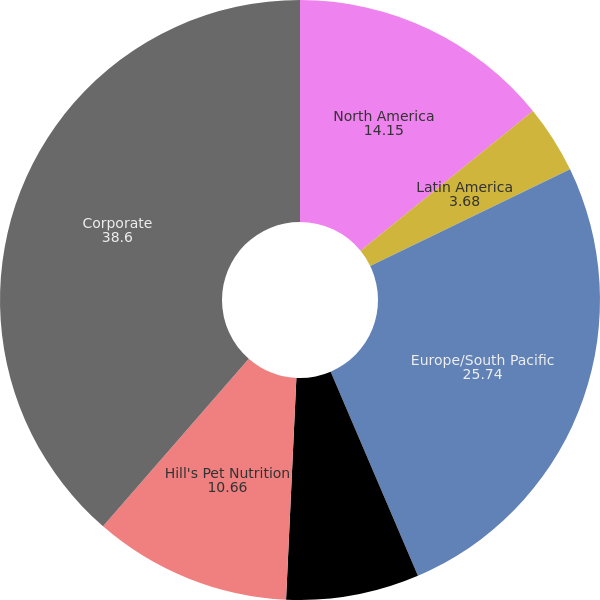Convert chart to OTSL. <chart><loc_0><loc_0><loc_500><loc_500><pie_chart><fcel>North America<fcel>Latin America<fcel>Europe/South Pacific<fcel>Africa/Eurasia<fcel>Hill's Pet Nutrition<fcel>Corporate<nl><fcel>14.15%<fcel>3.68%<fcel>25.74%<fcel>7.17%<fcel>10.66%<fcel>38.6%<nl></chart> 